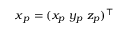Convert formula to latex. <formula><loc_0><loc_0><loc_500><loc_500>x _ { p } = ( x _ { p } \ y _ { p } \ z _ { p } ) ^ { \top }</formula> 